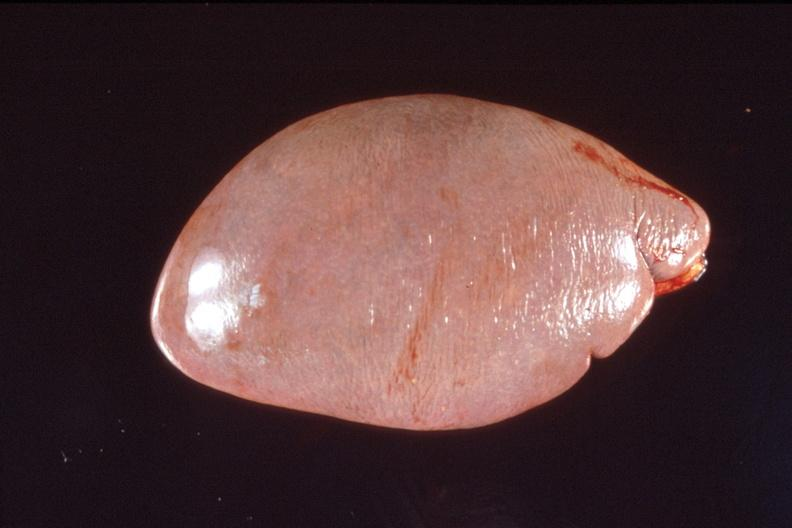what does this image show?
Answer the question using a single word or phrase. Spleen 